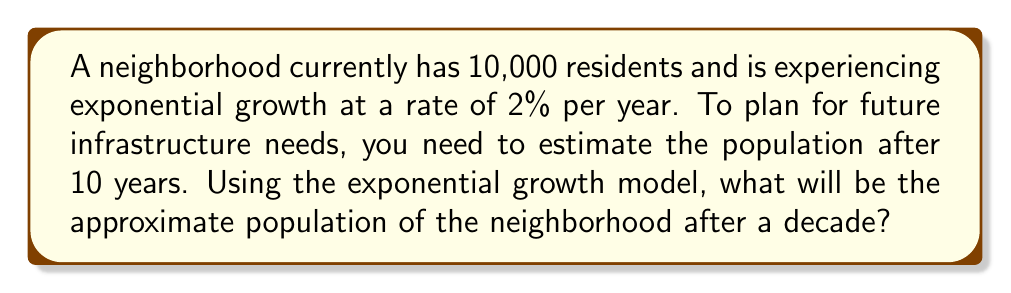Provide a solution to this math problem. To solve this problem, we'll use the exponential growth model:

$$P(t) = P_0 \cdot e^{rt}$$

Where:
$P(t)$ is the population at time $t$
$P_0$ is the initial population
$e$ is Euler's number (approximately 2.71828)
$r$ is the growth rate (as a decimal)
$t$ is the time in years

Given:
$P_0 = 10,000$
$r = 0.02$ (2% expressed as a decimal)
$t = 10$ years

Let's substitute these values into the equation:

$$P(10) = 10,000 \cdot e^{0.02 \cdot 10}$$

Now, let's solve this step-by-step:

1) First, calculate the exponent:
   $0.02 \cdot 10 = 0.2$

2) Our equation now looks like:
   $$P(10) = 10,000 \cdot e^{0.2}$$

3) Calculate $e^{0.2}$:
   $e^{0.2} \approx 1.2214$

4) Multiply this by the initial population:
   $10,000 \cdot 1.2214 = 12,214$

5) Round to the nearest whole number, as we can't have fractional people:
   $12,214$ residents

Therefore, after 10 years, the neighborhood is expected to have approximately 12,214 residents.
Answer: 12,214 residents 